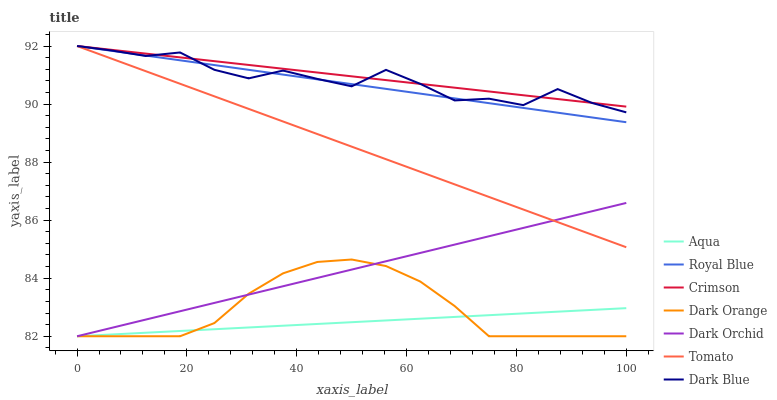Does Aqua have the minimum area under the curve?
Answer yes or no. Yes. Does Crimson have the maximum area under the curve?
Answer yes or no. Yes. Does Dark Orange have the minimum area under the curve?
Answer yes or no. No. Does Dark Orange have the maximum area under the curve?
Answer yes or no. No. Is Dark Orchid the smoothest?
Answer yes or no. Yes. Is Dark Blue the roughest?
Answer yes or no. Yes. Is Dark Orange the smoothest?
Answer yes or no. No. Is Dark Orange the roughest?
Answer yes or no. No. Does Dark Blue have the lowest value?
Answer yes or no. No. Does Crimson have the highest value?
Answer yes or no. Yes. Does Dark Orange have the highest value?
Answer yes or no. No. Is Dark Orchid less than Royal Blue?
Answer yes or no. Yes. Is Dark Blue greater than Dark Orange?
Answer yes or no. Yes. Does Dark Orchid intersect Royal Blue?
Answer yes or no. No. 